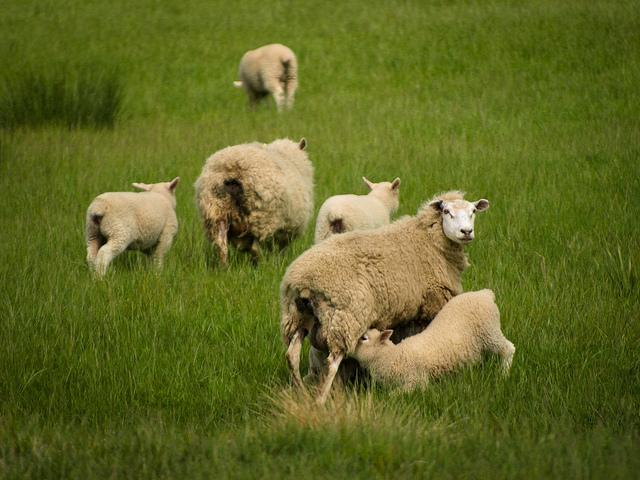What is the baby sheep doing? nursing 